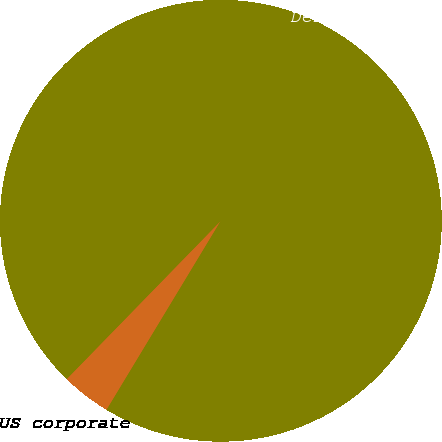Convert chart to OTSL. <chart><loc_0><loc_0><loc_500><loc_500><pie_chart><fcel>US corporate<fcel>Derivatives ^(e)<nl><fcel>3.64%<fcel>96.36%<nl></chart> 